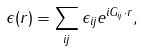Convert formula to latex. <formula><loc_0><loc_0><loc_500><loc_500>\epsilon ( r ) = \sum _ { i j } \epsilon _ { i j } e ^ { i G _ { i j } \cdot r } ,</formula> 